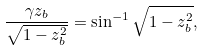<formula> <loc_0><loc_0><loc_500><loc_500>\frac { \gamma z _ { b } } { \sqrt { 1 - z _ { b } ^ { 2 } } } = \sin ^ { - 1 } \sqrt { 1 - z _ { b } ^ { 2 } } ,</formula> 